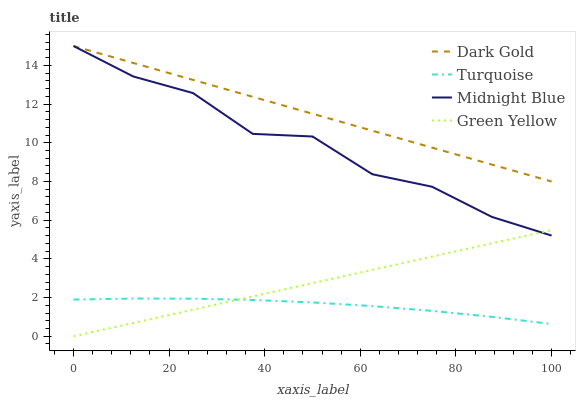Does Green Yellow have the minimum area under the curve?
Answer yes or no. No. Does Green Yellow have the maximum area under the curve?
Answer yes or no. No. Is Midnight Blue the smoothest?
Answer yes or no. No. Is Green Yellow the roughest?
Answer yes or no. No. Does Midnight Blue have the lowest value?
Answer yes or no. No. Does Green Yellow have the highest value?
Answer yes or no. No. Is Turquoise less than Midnight Blue?
Answer yes or no. Yes. Is Midnight Blue greater than Turquoise?
Answer yes or no. Yes. Does Turquoise intersect Midnight Blue?
Answer yes or no. No. 